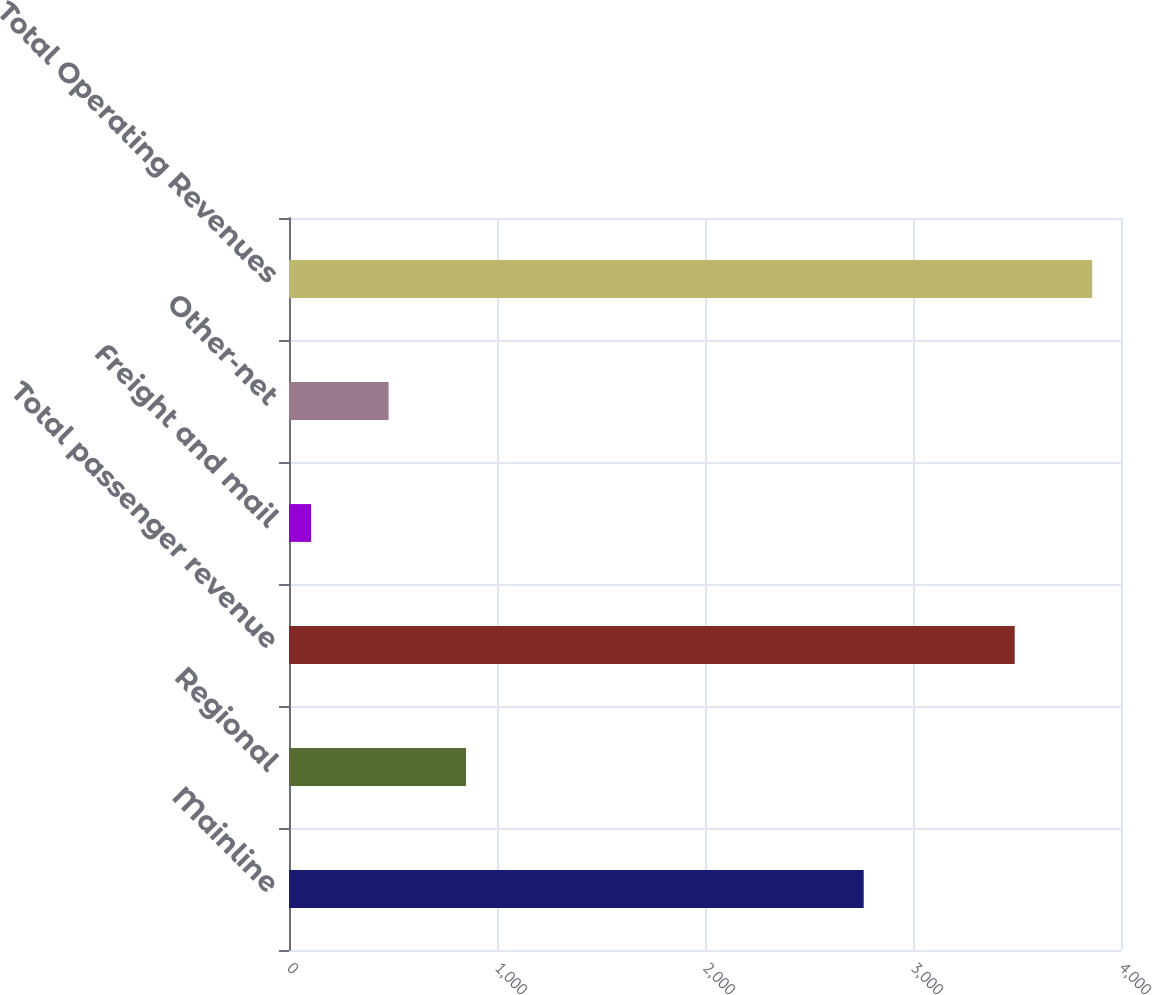<chart> <loc_0><loc_0><loc_500><loc_500><bar_chart><fcel>Mainline<fcel>Regional<fcel>Total passenger revenue<fcel>Freight and mail<fcel>Other-net<fcel>Total Operating Revenues<nl><fcel>2763<fcel>851.2<fcel>3489<fcel>106<fcel>478.6<fcel>3861.6<nl></chart> 